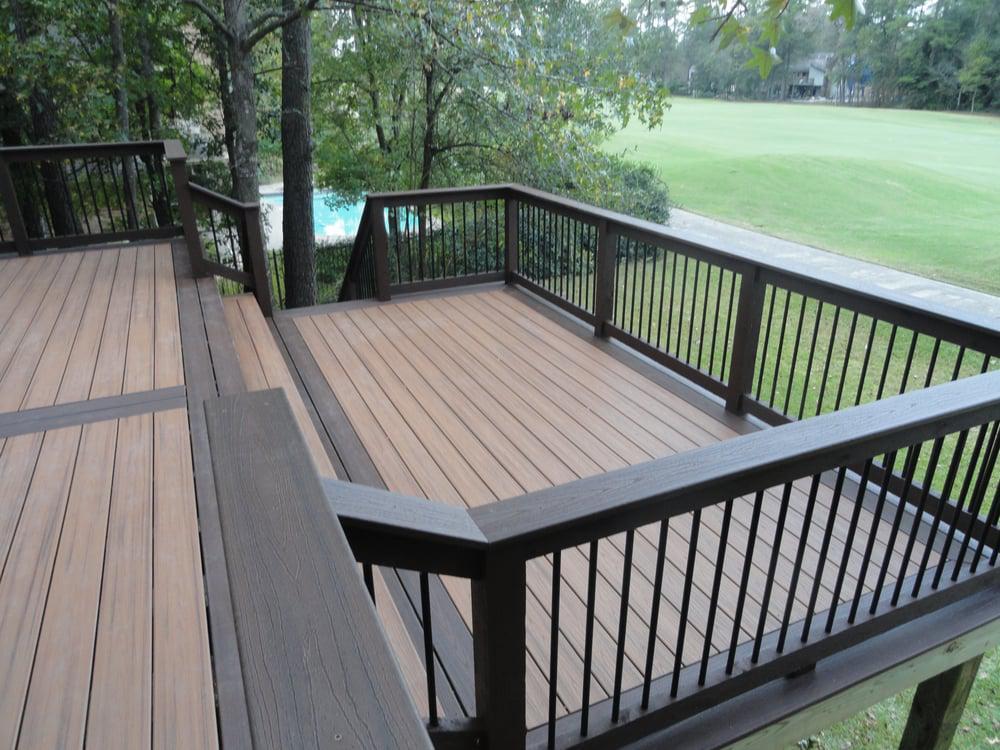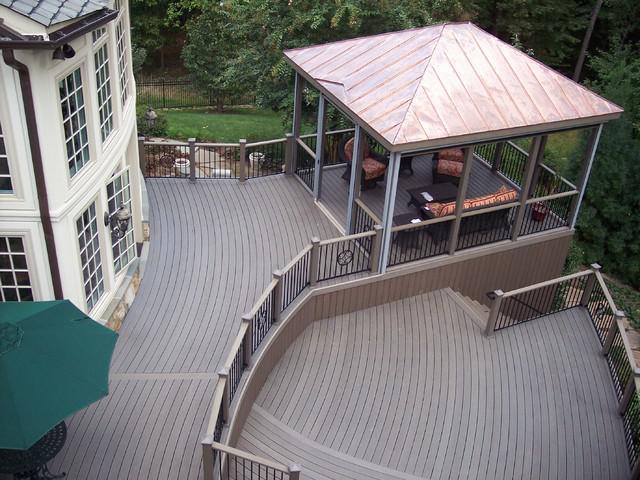The first image is the image on the left, the second image is the image on the right. Assess this claim about the two images: "One deck has dark grey flooring with no furniture on it, and the other deck has brown stained flooring, white rails, and furniture including a table with four chairs.". Correct or not? Answer yes or no. No. The first image is the image on the left, the second image is the image on the right. Examine the images to the left and right. Is the description "A table and 4 chairs sits on a wooden deck with a white banister." accurate? Answer yes or no. No. 